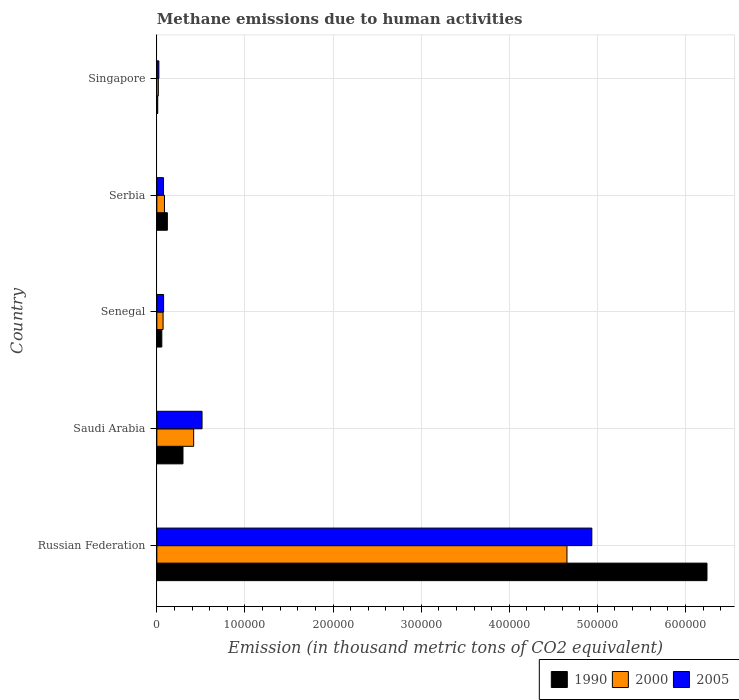How many different coloured bars are there?
Provide a short and direct response. 3. How many groups of bars are there?
Make the answer very short. 5. Are the number of bars on each tick of the Y-axis equal?
Make the answer very short. Yes. What is the label of the 1st group of bars from the top?
Give a very brief answer. Singapore. In how many cases, is the number of bars for a given country not equal to the number of legend labels?
Offer a terse response. 0. What is the amount of methane emitted in 1990 in Russian Federation?
Your response must be concise. 6.24e+05. Across all countries, what is the maximum amount of methane emitted in 2000?
Your response must be concise. 4.66e+05. Across all countries, what is the minimum amount of methane emitted in 1990?
Your answer should be compact. 986.7. In which country was the amount of methane emitted in 2005 maximum?
Your answer should be compact. Russian Federation. In which country was the amount of methane emitted in 1990 minimum?
Your answer should be compact. Singapore. What is the total amount of methane emitted in 2000 in the graph?
Your answer should be very brief. 5.25e+05. What is the difference between the amount of methane emitted in 2000 in Senegal and that in Serbia?
Provide a short and direct response. -1572.8. What is the difference between the amount of methane emitted in 2000 in Russian Federation and the amount of methane emitted in 2005 in Singapore?
Make the answer very short. 4.63e+05. What is the average amount of methane emitted in 2005 per country?
Provide a succinct answer. 1.13e+05. What is the difference between the amount of methane emitted in 2000 and amount of methane emitted in 1990 in Singapore?
Offer a very short reply. 703.9. What is the ratio of the amount of methane emitted in 1990 in Russian Federation to that in Singapore?
Offer a very short reply. 632.89. Is the amount of methane emitted in 2000 in Senegal less than that in Singapore?
Provide a short and direct response. No. Is the difference between the amount of methane emitted in 2000 in Russian Federation and Senegal greater than the difference between the amount of methane emitted in 1990 in Russian Federation and Senegal?
Your answer should be very brief. No. What is the difference between the highest and the second highest amount of methane emitted in 1990?
Ensure brevity in your answer.  5.95e+05. What is the difference between the highest and the lowest amount of methane emitted in 2000?
Give a very brief answer. 4.64e+05. In how many countries, is the amount of methane emitted in 1990 greater than the average amount of methane emitted in 1990 taken over all countries?
Your answer should be very brief. 1. What does the 3rd bar from the top in Senegal represents?
Your answer should be compact. 1990. Is it the case that in every country, the sum of the amount of methane emitted in 1990 and amount of methane emitted in 2000 is greater than the amount of methane emitted in 2005?
Give a very brief answer. Yes. How many bars are there?
Your answer should be compact. 15. Are all the bars in the graph horizontal?
Your answer should be very brief. Yes. Are the values on the major ticks of X-axis written in scientific E-notation?
Your response must be concise. No. Does the graph contain any zero values?
Offer a very short reply. No. Does the graph contain grids?
Your answer should be compact. Yes. How are the legend labels stacked?
Provide a short and direct response. Horizontal. What is the title of the graph?
Ensure brevity in your answer.  Methane emissions due to human activities. What is the label or title of the X-axis?
Your answer should be compact. Emission (in thousand metric tons of CO2 equivalent). What is the label or title of the Y-axis?
Keep it short and to the point. Country. What is the Emission (in thousand metric tons of CO2 equivalent) in 1990 in Russian Federation?
Your answer should be compact. 6.24e+05. What is the Emission (in thousand metric tons of CO2 equivalent) in 2000 in Russian Federation?
Offer a very short reply. 4.66e+05. What is the Emission (in thousand metric tons of CO2 equivalent) in 2005 in Russian Federation?
Your answer should be compact. 4.94e+05. What is the Emission (in thousand metric tons of CO2 equivalent) in 1990 in Saudi Arabia?
Your answer should be very brief. 2.97e+04. What is the Emission (in thousand metric tons of CO2 equivalent) in 2000 in Saudi Arabia?
Your response must be concise. 4.18e+04. What is the Emission (in thousand metric tons of CO2 equivalent) of 2005 in Saudi Arabia?
Provide a succinct answer. 5.13e+04. What is the Emission (in thousand metric tons of CO2 equivalent) of 1990 in Senegal?
Offer a very short reply. 5628.2. What is the Emission (in thousand metric tons of CO2 equivalent) in 2000 in Senegal?
Ensure brevity in your answer.  7078.1. What is the Emission (in thousand metric tons of CO2 equivalent) in 2005 in Senegal?
Make the answer very short. 7662.4. What is the Emission (in thousand metric tons of CO2 equivalent) of 1990 in Serbia?
Your answer should be compact. 1.19e+04. What is the Emission (in thousand metric tons of CO2 equivalent) of 2000 in Serbia?
Your answer should be very brief. 8650.9. What is the Emission (in thousand metric tons of CO2 equivalent) in 2005 in Serbia?
Provide a short and direct response. 7563. What is the Emission (in thousand metric tons of CO2 equivalent) of 1990 in Singapore?
Give a very brief answer. 986.7. What is the Emission (in thousand metric tons of CO2 equivalent) in 2000 in Singapore?
Your answer should be compact. 1690.6. What is the Emission (in thousand metric tons of CO2 equivalent) in 2005 in Singapore?
Ensure brevity in your answer.  2276.8. Across all countries, what is the maximum Emission (in thousand metric tons of CO2 equivalent) of 1990?
Your answer should be very brief. 6.24e+05. Across all countries, what is the maximum Emission (in thousand metric tons of CO2 equivalent) in 2000?
Provide a short and direct response. 4.66e+05. Across all countries, what is the maximum Emission (in thousand metric tons of CO2 equivalent) in 2005?
Offer a terse response. 4.94e+05. Across all countries, what is the minimum Emission (in thousand metric tons of CO2 equivalent) of 1990?
Keep it short and to the point. 986.7. Across all countries, what is the minimum Emission (in thousand metric tons of CO2 equivalent) of 2000?
Give a very brief answer. 1690.6. Across all countries, what is the minimum Emission (in thousand metric tons of CO2 equivalent) in 2005?
Make the answer very short. 2276.8. What is the total Emission (in thousand metric tons of CO2 equivalent) of 1990 in the graph?
Keep it short and to the point. 6.73e+05. What is the total Emission (in thousand metric tons of CO2 equivalent) of 2000 in the graph?
Ensure brevity in your answer.  5.25e+05. What is the total Emission (in thousand metric tons of CO2 equivalent) of 2005 in the graph?
Your answer should be compact. 5.63e+05. What is the difference between the Emission (in thousand metric tons of CO2 equivalent) in 1990 in Russian Federation and that in Saudi Arabia?
Give a very brief answer. 5.95e+05. What is the difference between the Emission (in thousand metric tons of CO2 equivalent) of 2000 in Russian Federation and that in Saudi Arabia?
Ensure brevity in your answer.  4.24e+05. What is the difference between the Emission (in thousand metric tons of CO2 equivalent) of 2005 in Russian Federation and that in Saudi Arabia?
Keep it short and to the point. 4.42e+05. What is the difference between the Emission (in thousand metric tons of CO2 equivalent) of 1990 in Russian Federation and that in Senegal?
Give a very brief answer. 6.19e+05. What is the difference between the Emission (in thousand metric tons of CO2 equivalent) of 2000 in Russian Federation and that in Senegal?
Keep it short and to the point. 4.58e+05. What is the difference between the Emission (in thousand metric tons of CO2 equivalent) in 2005 in Russian Federation and that in Senegal?
Offer a terse response. 4.86e+05. What is the difference between the Emission (in thousand metric tons of CO2 equivalent) in 1990 in Russian Federation and that in Serbia?
Your answer should be compact. 6.13e+05. What is the difference between the Emission (in thousand metric tons of CO2 equivalent) in 2000 in Russian Federation and that in Serbia?
Provide a succinct answer. 4.57e+05. What is the difference between the Emission (in thousand metric tons of CO2 equivalent) of 2005 in Russian Federation and that in Serbia?
Give a very brief answer. 4.86e+05. What is the difference between the Emission (in thousand metric tons of CO2 equivalent) in 1990 in Russian Federation and that in Singapore?
Provide a succinct answer. 6.23e+05. What is the difference between the Emission (in thousand metric tons of CO2 equivalent) of 2000 in Russian Federation and that in Singapore?
Ensure brevity in your answer.  4.64e+05. What is the difference between the Emission (in thousand metric tons of CO2 equivalent) in 2005 in Russian Federation and that in Singapore?
Your answer should be compact. 4.91e+05. What is the difference between the Emission (in thousand metric tons of CO2 equivalent) in 1990 in Saudi Arabia and that in Senegal?
Your answer should be very brief. 2.40e+04. What is the difference between the Emission (in thousand metric tons of CO2 equivalent) of 2000 in Saudi Arabia and that in Senegal?
Give a very brief answer. 3.47e+04. What is the difference between the Emission (in thousand metric tons of CO2 equivalent) in 2005 in Saudi Arabia and that in Senegal?
Make the answer very short. 4.36e+04. What is the difference between the Emission (in thousand metric tons of CO2 equivalent) of 1990 in Saudi Arabia and that in Serbia?
Your response must be concise. 1.77e+04. What is the difference between the Emission (in thousand metric tons of CO2 equivalent) in 2000 in Saudi Arabia and that in Serbia?
Your response must be concise. 3.31e+04. What is the difference between the Emission (in thousand metric tons of CO2 equivalent) of 2005 in Saudi Arabia and that in Serbia?
Your response must be concise. 4.37e+04. What is the difference between the Emission (in thousand metric tons of CO2 equivalent) of 1990 in Saudi Arabia and that in Singapore?
Offer a very short reply. 2.87e+04. What is the difference between the Emission (in thousand metric tons of CO2 equivalent) of 2000 in Saudi Arabia and that in Singapore?
Your answer should be very brief. 4.01e+04. What is the difference between the Emission (in thousand metric tons of CO2 equivalent) in 2005 in Saudi Arabia and that in Singapore?
Offer a terse response. 4.90e+04. What is the difference between the Emission (in thousand metric tons of CO2 equivalent) of 1990 in Senegal and that in Serbia?
Your response must be concise. -6311.5. What is the difference between the Emission (in thousand metric tons of CO2 equivalent) of 2000 in Senegal and that in Serbia?
Your answer should be compact. -1572.8. What is the difference between the Emission (in thousand metric tons of CO2 equivalent) of 2005 in Senegal and that in Serbia?
Make the answer very short. 99.4. What is the difference between the Emission (in thousand metric tons of CO2 equivalent) in 1990 in Senegal and that in Singapore?
Make the answer very short. 4641.5. What is the difference between the Emission (in thousand metric tons of CO2 equivalent) in 2000 in Senegal and that in Singapore?
Offer a very short reply. 5387.5. What is the difference between the Emission (in thousand metric tons of CO2 equivalent) in 2005 in Senegal and that in Singapore?
Your answer should be very brief. 5385.6. What is the difference between the Emission (in thousand metric tons of CO2 equivalent) in 1990 in Serbia and that in Singapore?
Give a very brief answer. 1.10e+04. What is the difference between the Emission (in thousand metric tons of CO2 equivalent) of 2000 in Serbia and that in Singapore?
Offer a terse response. 6960.3. What is the difference between the Emission (in thousand metric tons of CO2 equivalent) of 2005 in Serbia and that in Singapore?
Keep it short and to the point. 5286.2. What is the difference between the Emission (in thousand metric tons of CO2 equivalent) in 1990 in Russian Federation and the Emission (in thousand metric tons of CO2 equivalent) in 2000 in Saudi Arabia?
Your answer should be compact. 5.83e+05. What is the difference between the Emission (in thousand metric tons of CO2 equivalent) of 1990 in Russian Federation and the Emission (in thousand metric tons of CO2 equivalent) of 2005 in Saudi Arabia?
Offer a terse response. 5.73e+05. What is the difference between the Emission (in thousand metric tons of CO2 equivalent) of 2000 in Russian Federation and the Emission (in thousand metric tons of CO2 equivalent) of 2005 in Saudi Arabia?
Provide a short and direct response. 4.14e+05. What is the difference between the Emission (in thousand metric tons of CO2 equivalent) in 1990 in Russian Federation and the Emission (in thousand metric tons of CO2 equivalent) in 2000 in Senegal?
Provide a succinct answer. 6.17e+05. What is the difference between the Emission (in thousand metric tons of CO2 equivalent) in 1990 in Russian Federation and the Emission (in thousand metric tons of CO2 equivalent) in 2005 in Senegal?
Provide a succinct answer. 6.17e+05. What is the difference between the Emission (in thousand metric tons of CO2 equivalent) of 2000 in Russian Federation and the Emission (in thousand metric tons of CO2 equivalent) of 2005 in Senegal?
Provide a succinct answer. 4.58e+05. What is the difference between the Emission (in thousand metric tons of CO2 equivalent) in 1990 in Russian Federation and the Emission (in thousand metric tons of CO2 equivalent) in 2000 in Serbia?
Offer a terse response. 6.16e+05. What is the difference between the Emission (in thousand metric tons of CO2 equivalent) of 1990 in Russian Federation and the Emission (in thousand metric tons of CO2 equivalent) of 2005 in Serbia?
Give a very brief answer. 6.17e+05. What is the difference between the Emission (in thousand metric tons of CO2 equivalent) in 2000 in Russian Federation and the Emission (in thousand metric tons of CO2 equivalent) in 2005 in Serbia?
Offer a terse response. 4.58e+05. What is the difference between the Emission (in thousand metric tons of CO2 equivalent) of 1990 in Russian Federation and the Emission (in thousand metric tons of CO2 equivalent) of 2000 in Singapore?
Offer a very short reply. 6.23e+05. What is the difference between the Emission (in thousand metric tons of CO2 equivalent) in 1990 in Russian Federation and the Emission (in thousand metric tons of CO2 equivalent) in 2005 in Singapore?
Keep it short and to the point. 6.22e+05. What is the difference between the Emission (in thousand metric tons of CO2 equivalent) in 2000 in Russian Federation and the Emission (in thousand metric tons of CO2 equivalent) in 2005 in Singapore?
Ensure brevity in your answer.  4.63e+05. What is the difference between the Emission (in thousand metric tons of CO2 equivalent) in 1990 in Saudi Arabia and the Emission (in thousand metric tons of CO2 equivalent) in 2000 in Senegal?
Your response must be concise. 2.26e+04. What is the difference between the Emission (in thousand metric tons of CO2 equivalent) of 1990 in Saudi Arabia and the Emission (in thousand metric tons of CO2 equivalent) of 2005 in Senegal?
Make the answer very short. 2.20e+04. What is the difference between the Emission (in thousand metric tons of CO2 equivalent) of 2000 in Saudi Arabia and the Emission (in thousand metric tons of CO2 equivalent) of 2005 in Senegal?
Your answer should be compact. 3.41e+04. What is the difference between the Emission (in thousand metric tons of CO2 equivalent) in 1990 in Saudi Arabia and the Emission (in thousand metric tons of CO2 equivalent) in 2000 in Serbia?
Provide a succinct answer. 2.10e+04. What is the difference between the Emission (in thousand metric tons of CO2 equivalent) in 1990 in Saudi Arabia and the Emission (in thousand metric tons of CO2 equivalent) in 2005 in Serbia?
Your answer should be very brief. 2.21e+04. What is the difference between the Emission (in thousand metric tons of CO2 equivalent) in 2000 in Saudi Arabia and the Emission (in thousand metric tons of CO2 equivalent) in 2005 in Serbia?
Offer a very short reply. 3.42e+04. What is the difference between the Emission (in thousand metric tons of CO2 equivalent) in 1990 in Saudi Arabia and the Emission (in thousand metric tons of CO2 equivalent) in 2000 in Singapore?
Your answer should be very brief. 2.80e+04. What is the difference between the Emission (in thousand metric tons of CO2 equivalent) in 1990 in Saudi Arabia and the Emission (in thousand metric tons of CO2 equivalent) in 2005 in Singapore?
Provide a short and direct response. 2.74e+04. What is the difference between the Emission (in thousand metric tons of CO2 equivalent) in 2000 in Saudi Arabia and the Emission (in thousand metric tons of CO2 equivalent) in 2005 in Singapore?
Provide a short and direct response. 3.95e+04. What is the difference between the Emission (in thousand metric tons of CO2 equivalent) in 1990 in Senegal and the Emission (in thousand metric tons of CO2 equivalent) in 2000 in Serbia?
Your answer should be very brief. -3022.7. What is the difference between the Emission (in thousand metric tons of CO2 equivalent) in 1990 in Senegal and the Emission (in thousand metric tons of CO2 equivalent) in 2005 in Serbia?
Provide a succinct answer. -1934.8. What is the difference between the Emission (in thousand metric tons of CO2 equivalent) of 2000 in Senegal and the Emission (in thousand metric tons of CO2 equivalent) of 2005 in Serbia?
Make the answer very short. -484.9. What is the difference between the Emission (in thousand metric tons of CO2 equivalent) in 1990 in Senegal and the Emission (in thousand metric tons of CO2 equivalent) in 2000 in Singapore?
Keep it short and to the point. 3937.6. What is the difference between the Emission (in thousand metric tons of CO2 equivalent) in 1990 in Senegal and the Emission (in thousand metric tons of CO2 equivalent) in 2005 in Singapore?
Offer a terse response. 3351.4. What is the difference between the Emission (in thousand metric tons of CO2 equivalent) of 2000 in Senegal and the Emission (in thousand metric tons of CO2 equivalent) of 2005 in Singapore?
Offer a very short reply. 4801.3. What is the difference between the Emission (in thousand metric tons of CO2 equivalent) in 1990 in Serbia and the Emission (in thousand metric tons of CO2 equivalent) in 2000 in Singapore?
Ensure brevity in your answer.  1.02e+04. What is the difference between the Emission (in thousand metric tons of CO2 equivalent) in 1990 in Serbia and the Emission (in thousand metric tons of CO2 equivalent) in 2005 in Singapore?
Offer a terse response. 9662.9. What is the difference between the Emission (in thousand metric tons of CO2 equivalent) in 2000 in Serbia and the Emission (in thousand metric tons of CO2 equivalent) in 2005 in Singapore?
Ensure brevity in your answer.  6374.1. What is the average Emission (in thousand metric tons of CO2 equivalent) of 1990 per country?
Make the answer very short. 1.35e+05. What is the average Emission (in thousand metric tons of CO2 equivalent) of 2000 per country?
Provide a short and direct response. 1.05e+05. What is the average Emission (in thousand metric tons of CO2 equivalent) of 2005 per country?
Your answer should be very brief. 1.13e+05. What is the difference between the Emission (in thousand metric tons of CO2 equivalent) in 1990 and Emission (in thousand metric tons of CO2 equivalent) in 2000 in Russian Federation?
Give a very brief answer. 1.59e+05. What is the difference between the Emission (in thousand metric tons of CO2 equivalent) of 1990 and Emission (in thousand metric tons of CO2 equivalent) of 2005 in Russian Federation?
Your response must be concise. 1.31e+05. What is the difference between the Emission (in thousand metric tons of CO2 equivalent) of 2000 and Emission (in thousand metric tons of CO2 equivalent) of 2005 in Russian Federation?
Provide a short and direct response. -2.82e+04. What is the difference between the Emission (in thousand metric tons of CO2 equivalent) in 1990 and Emission (in thousand metric tons of CO2 equivalent) in 2000 in Saudi Arabia?
Provide a succinct answer. -1.21e+04. What is the difference between the Emission (in thousand metric tons of CO2 equivalent) of 1990 and Emission (in thousand metric tons of CO2 equivalent) of 2005 in Saudi Arabia?
Your answer should be very brief. -2.16e+04. What is the difference between the Emission (in thousand metric tons of CO2 equivalent) in 2000 and Emission (in thousand metric tons of CO2 equivalent) in 2005 in Saudi Arabia?
Make the answer very short. -9501.6. What is the difference between the Emission (in thousand metric tons of CO2 equivalent) of 1990 and Emission (in thousand metric tons of CO2 equivalent) of 2000 in Senegal?
Keep it short and to the point. -1449.9. What is the difference between the Emission (in thousand metric tons of CO2 equivalent) in 1990 and Emission (in thousand metric tons of CO2 equivalent) in 2005 in Senegal?
Make the answer very short. -2034.2. What is the difference between the Emission (in thousand metric tons of CO2 equivalent) of 2000 and Emission (in thousand metric tons of CO2 equivalent) of 2005 in Senegal?
Make the answer very short. -584.3. What is the difference between the Emission (in thousand metric tons of CO2 equivalent) of 1990 and Emission (in thousand metric tons of CO2 equivalent) of 2000 in Serbia?
Your answer should be very brief. 3288.8. What is the difference between the Emission (in thousand metric tons of CO2 equivalent) of 1990 and Emission (in thousand metric tons of CO2 equivalent) of 2005 in Serbia?
Ensure brevity in your answer.  4376.7. What is the difference between the Emission (in thousand metric tons of CO2 equivalent) in 2000 and Emission (in thousand metric tons of CO2 equivalent) in 2005 in Serbia?
Offer a terse response. 1087.9. What is the difference between the Emission (in thousand metric tons of CO2 equivalent) in 1990 and Emission (in thousand metric tons of CO2 equivalent) in 2000 in Singapore?
Provide a short and direct response. -703.9. What is the difference between the Emission (in thousand metric tons of CO2 equivalent) in 1990 and Emission (in thousand metric tons of CO2 equivalent) in 2005 in Singapore?
Give a very brief answer. -1290.1. What is the difference between the Emission (in thousand metric tons of CO2 equivalent) in 2000 and Emission (in thousand metric tons of CO2 equivalent) in 2005 in Singapore?
Ensure brevity in your answer.  -586.2. What is the ratio of the Emission (in thousand metric tons of CO2 equivalent) in 1990 in Russian Federation to that in Saudi Arabia?
Your answer should be compact. 21.05. What is the ratio of the Emission (in thousand metric tons of CO2 equivalent) of 2000 in Russian Federation to that in Saudi Arabia?
Provide a short and direct response. 11.14. What is the ratio of the Emission (in thousand metric tons of CO2 equivalent) of 2005 in Russian Federation to that in Saudi Arabia?
Your answer should be very brief. 9.62. What is the ratio of the Emission (in thousand metric tons of CO2 equivalent) of 1990 in Russian Federation to that in Senegal?
Provide a short and direct response. 110.95. What is the ratio of the Emission (in thousand metric tons of CO2 equivalent) of 2000 in Russian Federation to that in Senegal?
Your answer should be very brief. 65.77. What is the ratio of the Emission (in thousand metric tons of CO2 equivalent) in 2005 in Russian Federation to that in Senegal?
Offer a terse response. 64.44. What is the ratio of the Emission (in thousand metric tons of CO2 equivalent) in 1990 in Russian Federation to that in Serbia?
Provide a succinct answer. 52.3. What is the ratio of the Emission (in thousand metric tons of CO2 equivalent) in 2000 in Russian Federation to that in Serbia?
Your answer should be compact. 53.81. What is the ratio of the Emission (in thousand metric tons of CO2 equivalent) of 2005 in Russian Federation to that in Serbia?
Provide a succinct answer. 65.29. What is the ratio of the Emission (in thousand metric tons of CO2 equivalent) in 1990 in Russian Federation to that in Singapore?
Provide a short and direct response. 632.89. What is the ratio of the Emission (in thousand metric tons of CO2 equivalent) of 2000 in Russian Federation to that in Singapore?
Your response must be concise. 275.37. What is the ratio of the Emission (in thousand metric tons of CO2 equivalent) of 2005 in Russian Federation to that in Singapore?
Keep it short and to the point. 216.86. What is the ratio of the Emission (in thousand metric tons of CO2 equivalent) of 1990 in Saudi Arabia to that in Senegal?
Make the answer very short. 5.27. What is the ratio of the Emission (in thousand metric tons of CO2 equivalent) of 2000 in Saudi Arabia to that in Senegal?
Give a very brief answer. 5.91. What is the ratio of the Emission (in thousand metric tons of CO2 equivalent) in 2005 in Saudi Arabia to that in Senegal?
Keep it short and to the point. 6.69. What is the ratio of the Emission (in thousand metric tons of CO2 equivalent) in 1990 in Saudi Arabia to that in Serbia?
Your response must be concise. 2.49. What is the ratio of the Emission (in thousand metric tons of CO2 equivalent) in 2000 in Saudi Arabia to that in Serbia?
Ensure brevity in your answer.  4.83. What is the ratio of the Emission (in thousand metric tons of CO2 equivalent) in 2005 in Saudi Arabia to that in Serbia?
Give a very brief answer. 6.78. What is the ratio of the Emission (in thousand metric tons of CO2 equivalent) in 1990 in Saudi Arabia to that in Singapore?
Ensure brevity in your answer.  30.07. What is the ratio of the Emission (in thousand metric tons of CO2 equivalent) of 2000 in Saudi Arabia to that in Singapore?
Provide a succinct answer. 24.72. What is the ratio of the Emission (in thousand metric tons of CO2 equivalent) of 2005 in Saudi Arabia to that in Singapore?
Your answer should be compact. 22.53. What is the ratio of the Emission (in thousand metric tons of CO2 equivalent) in 1990 in Senegal to that in Serbia?
Offer a terse response. 0.47. What is the ratio of the Emission (in thousand metric tons of CO2 equivalent) in 2000 in Senegal to that in Serbia?
Your answer should be very brief. 0.82. What is the ratio of the Emission (in thousand metric tons of CO2 equivalent) of 2005 in Senegal to that in Serbia?
Offer a terse response. 1.01. What is the ratio of the Emission (in thousand metric tons of CO2 equivalent) in 1990 in Senegal to that in Singapore?
Your answer should be compact. 5.7. What is the ratio of the Emission (in thousand metric tons of CO2 equivalent) of 2000 in Senegal to that in Singapore?
Offer a terse response. 4.19. What is the ratio of the Emission (in thousand metric tons of CO2 equivalent) of 2005 in Senegal to that in Singapore?
Your answer should be very brief. 3.37. What is the ratio of the Emission (in thousand metric tons of CO2 equivalent) in 1990 in Serbia to that in Singapore?
Your response must be concise. 12.1. What is the ratio of the Emission (in thousand metric tons of CO2 equivalent) of 2000 in Serbia to that in Singapore?
Provide a short and direct response. 5.12. What is the ratio of the Emission (in thousand metric tons of CO2 equivalent) of 2005 in Serbia to that in Singapore?
Offer a very short reply. 3.32. What is the difference between the highest and the second highest Emission (in thousand metric tons of CO2 equivalent) of 1990?
Your answer should be very brief. 5.95e+05. What is the difference between the highest and the second highest Emission (in thousand metric tons of CO2 equivalent) of 2000?
Your answer should be very brief. 4.24e+05. What is the difference between the highest and the second highest Emission (in thousand metric tons of CO2 equivalent) in 2005?
Your answer should be very brief. 4.42e+05. What is the difference between the highest and the lowest Emission (in thousand metric tons of CO2 equivalent) in 1990?
Offer a terse response. 6.23e+05. What is the difference between the highest and the lowest Emission (in thousand metric tons of CO2 equivalent) in 2000?
Keep it short and to the point. 4.64e+05. What is the difference between the highest and the lowest Emission (in thousand metric tons of CO2 equivalent) of 2005?
Provide a succinct answer. 4.91e+05. 